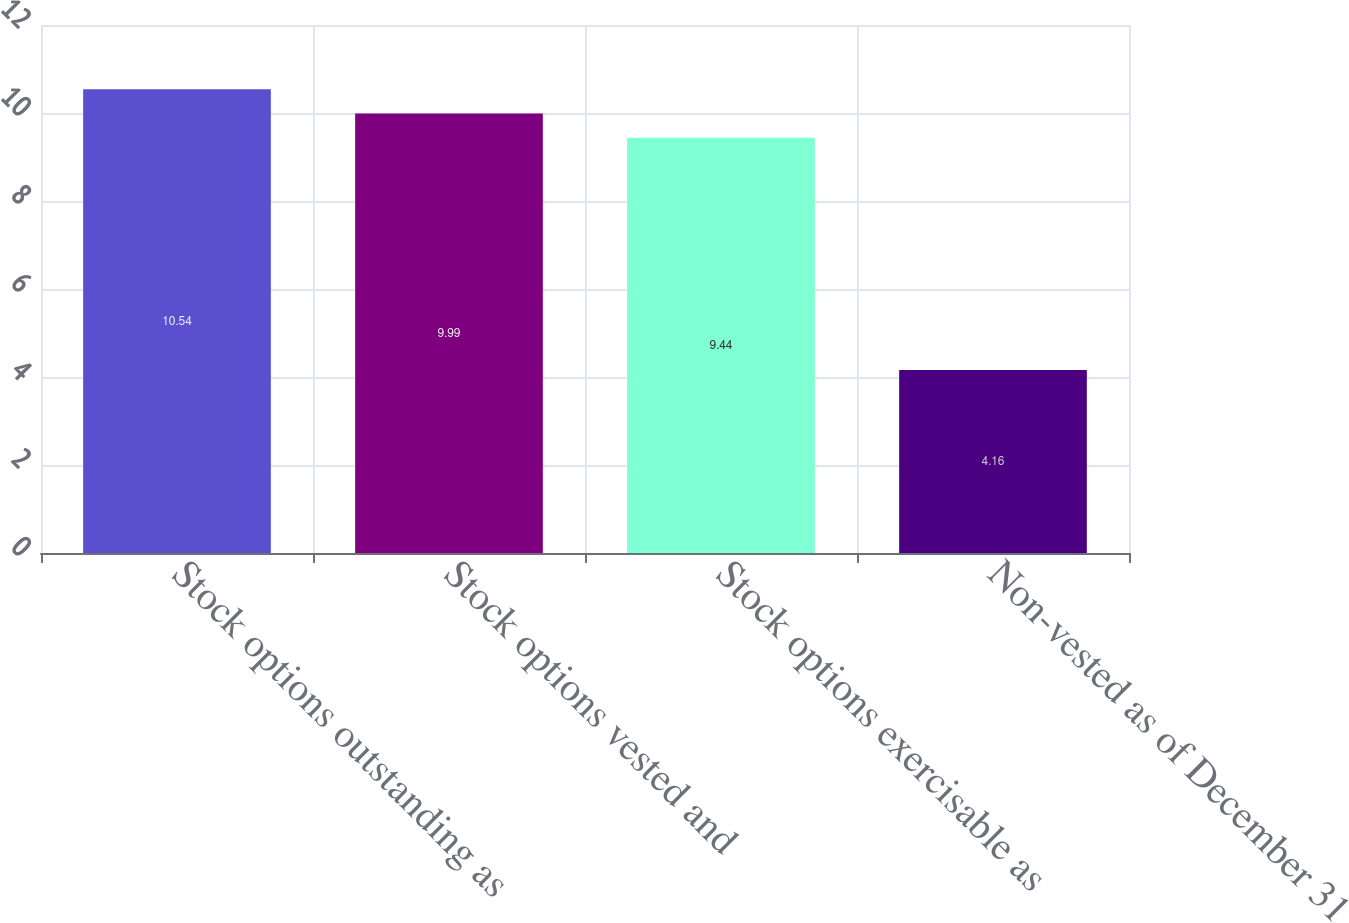Convert chart. <chart><loc_0><loc_0><loc_500><loc_500><bar_chart><fcel>Stock options outstanding as<fcel>Stock options vested and<fcel>Stock options exercisable as<fcel>Non-vested as of December 31<nl><fcel>10.54<fcel>9.99<fcel>9.44<fcel>4.16<nl></chart> 